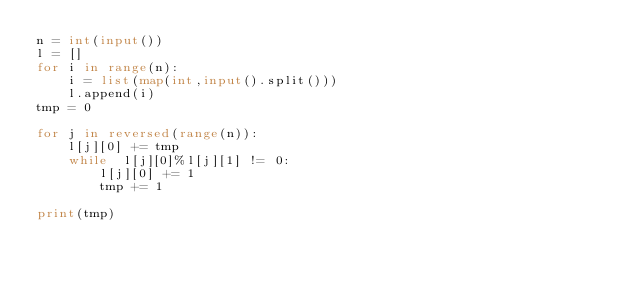Convert code to text. <code><loc_0><loc_0><loc_500><loc_500><_Python_>n = int(input())
l = []
for i in range(n):
    i = list(map(int,input().split()))
    l.append(i)
tmp = 0

for j in reversed(range(n)):
    l[j][0] += tmp
    while  l[j][0]%l[j][1] != 0:
        l[j][0] += 1
        tmp += 1

print(tmp)</code> 